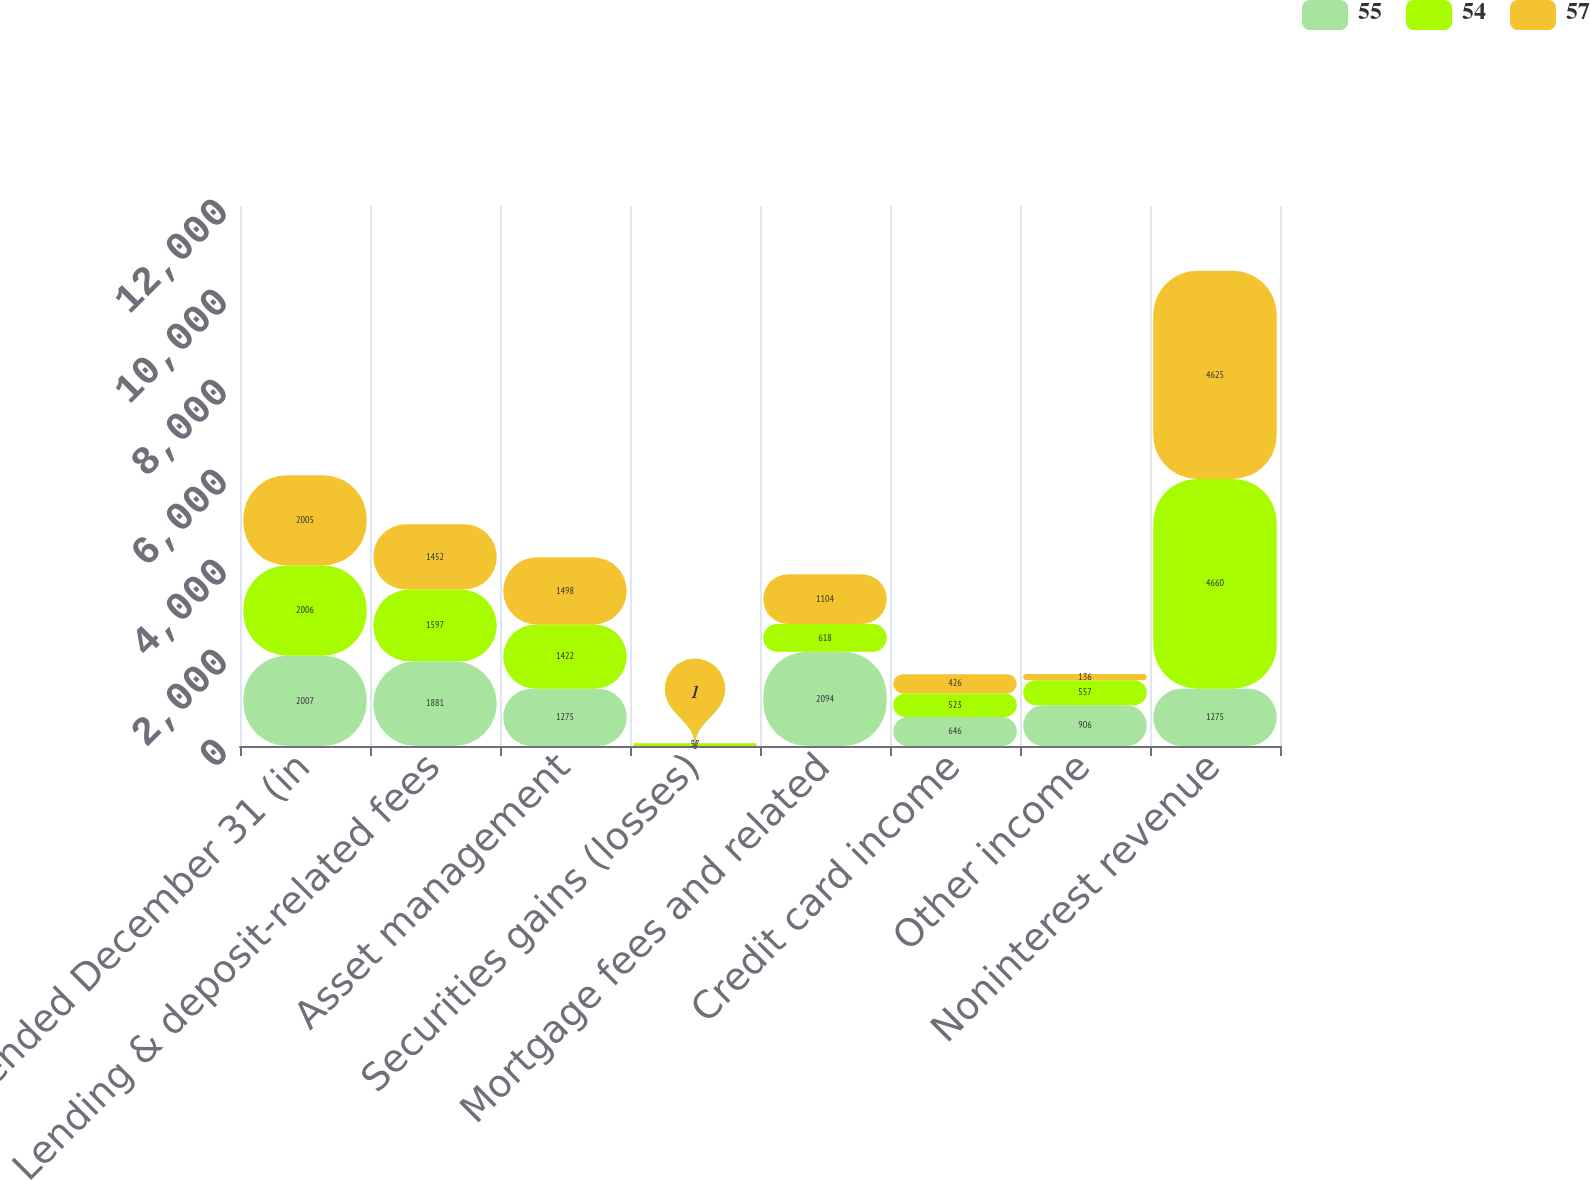Convert chart. <chart><loc_0><loc_0><loc_500><loc_500><stacked_bar_chart><ecel><fcel>Year ended December 31 (in<fcel>Lending & deposit-related fees<fcel>Asset management<fcel>Securities gains (losses)<fcel>Mortgage fees and related<fcel>Credit card income<fcel>Other income<fcel>Noninterest revenue<nl><fcel>55<fcel>2007<fcel>1881<fcel>1275<fcel>1<fcel>2094<fcel>646<fcel>906<fcel>1275<nl><fcel>54<fcel>2006<fcel>1597<fcel>1422<fcel>57<fcel>618<fcel>523<fcel>557<fcel>4660<nl><fcel>57<fcel>2005<fcel>1452<fcel>1498<fcel>9<fcel>1104<fcel>426<fcel>136<fcel>4625<nl></chart> 